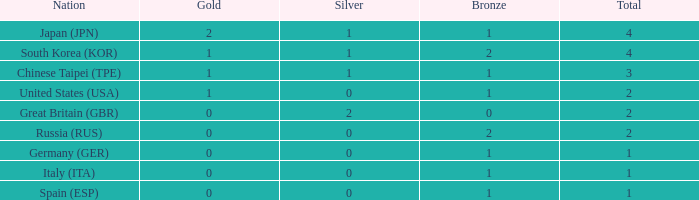What is the smallest number of gold of a country of rank 6, with 2 bronzes? None. Could you parse the entire table? {'header': ['Nation', 'Gold', 'Silver', 'Bronze', 'Total'], 'rows': [['Japan (JPN)', '2', '1', '1', '4'], ['South Korea (KOR)', '1', '1', '2', '4'], ['Chinese Taipei (TPE)', '1', '1', '1', '3'], ['United States (USA)', '1', '0', '1', '2'], ['Great Britain (GBR)', '0', '2', '0', '2'], ['Russia (RUS)', '0', '0', '2', '2'], ['Germany (GER)', '0', '0', '1', '1'], ['Italy (ITA)', '0', '0', '1', '1'], ['Spain (ESP)', '0', '0', '1', '1']]} 